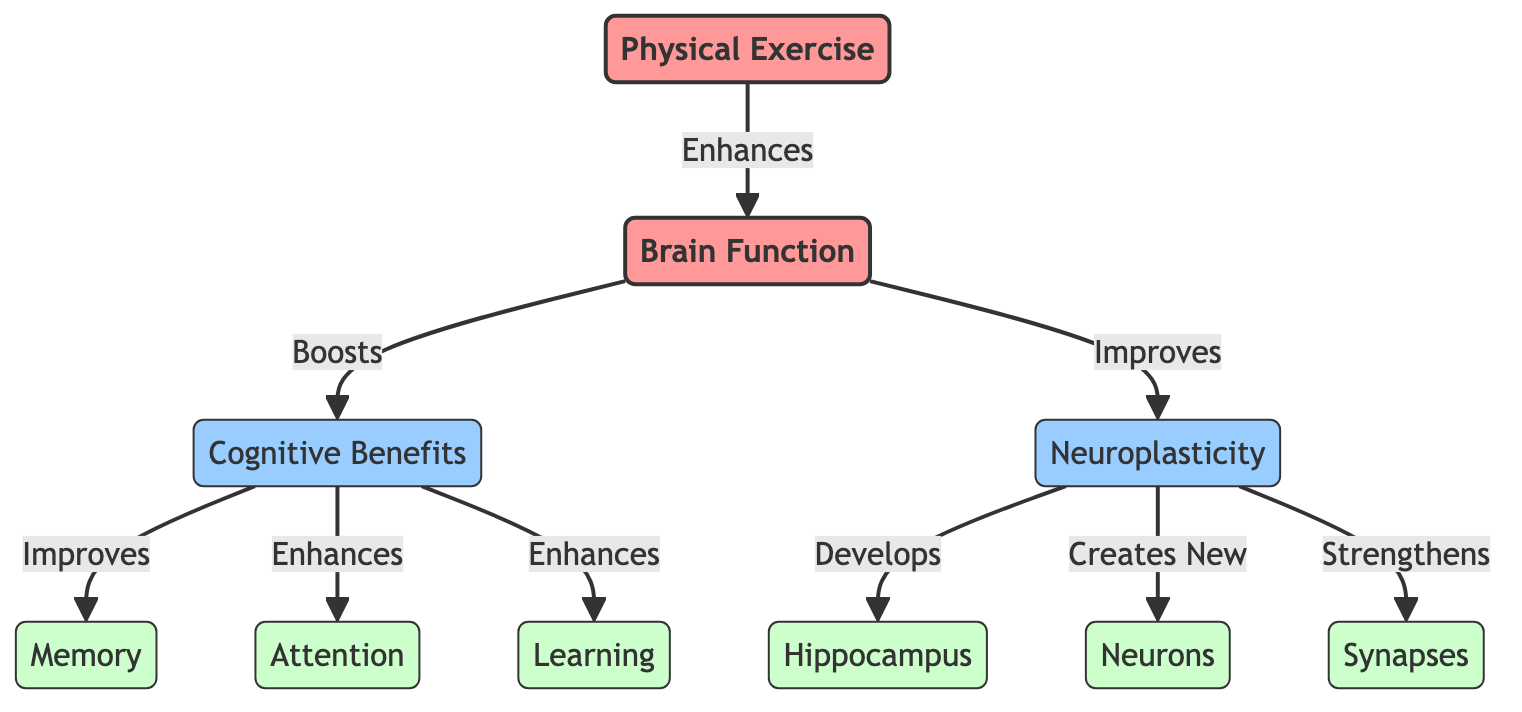What is the main effect of Physical Exercise? Physical Exercise directly enhances Brain Function, as indicated by the arrow leading from "Physical Exercise" to "Brain Function" labeled "Enhances."
Answer: Enhances How many cognitive benefits are listed in the diagram? There are three cognitive benefits shown: Memory, Attention, and Learning. These benefits are represented as secondary nodes under "Cognitive Benefits."
Answer: Three Which brain structure is developed due to Neuroplasticity? The diagram indicates that Neuroplasticity develops the Hippocampus, as shown by the arrow connecting "Neuroplasticity" to "Hippocampus" labeled "Develops."
Answer: Hippocampus What does Brain Function improve with physical exercise? The diagram shows that Brain Function improves Neuroplasticity, as represented by the arrow from "Brain Function" to "Neuroplasticity" labeled "Improves."
Answer: Neuroplasticity What are the new cells created by Neuroplasticity? According to the diagram, Neuroplasticity creates new Neurons, as indicated by the arrow from "Neuroplasticity" to "Neurons" labeled "Creates New."
Answer: Neurons How do Cognitive Benefits affect Memory? The diagram illustrates that Cognitive Benefits improve Memory, shown by the arrow pointing from "Cognitive Benefits" to "Memory" labeled "Improves."
Answer: Improves What is the relationship between Attention and Cognitive Benefits? The diagram indicates that Cognitive Benefits enhance Attention, as shown by the arrow from "Cognitive Benefits" to "Attention" labeled "Enhances."
Answer: Enhances Which aspect represents the connection between Neuroplasticity and Synapses? The diagram indicates that Neuroplasticity strengthens Synapses, demonstrated by the arrow from "Neuroplasticity" to "Synapses" labeled "Strengthens."
Answer: Strengthens What happens to Synapses due to Neuroplasticity? Neuroplasticity leads to the strengthening of Synapses, as clearly shown in the diagram by the connection labeled "Strengthens."
Answer: Strengthens 